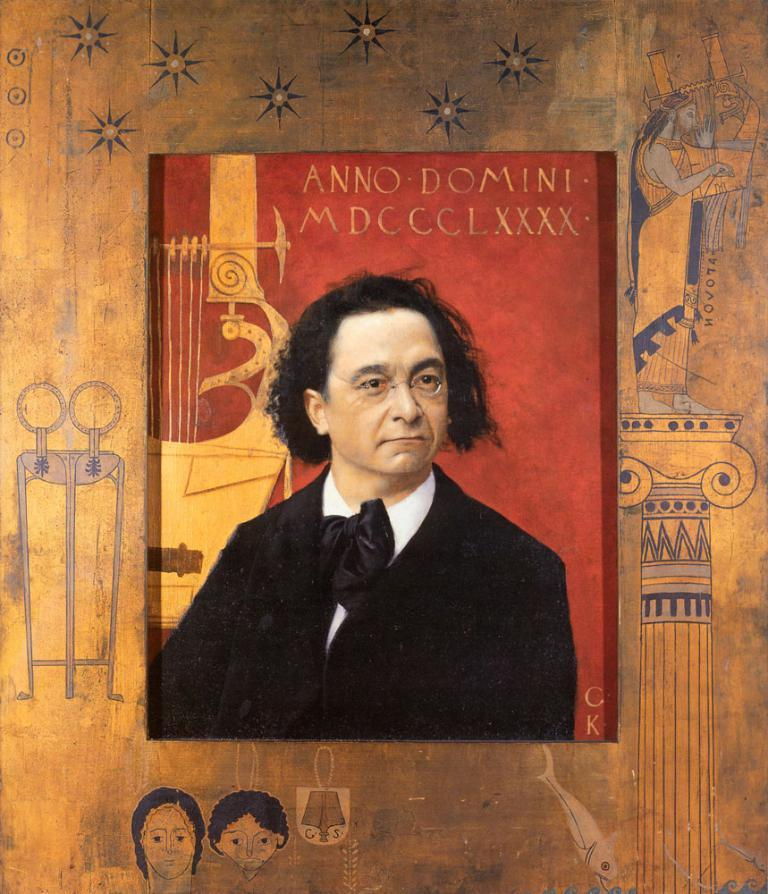What is the main object in the image? There is a box-like object in the image. Who is on the box-like object? A person wearing specs is on the box-like object. What else can be seen in the image besides the box and the person? There is text in the image. What can be found in the background of the image? There are drawings on an object in the background of the image. Can you tell me how many bees are buzzing around the person on the box-like object? There are no bees present in the image; the focus is on the person wearing specs on the box-like object. What color is the pin holding the person's eye open? There is no pin or eye mentioned in the image; the focus is on the person wearing specs on the box-like object and the presence of text and drawings in the background. 